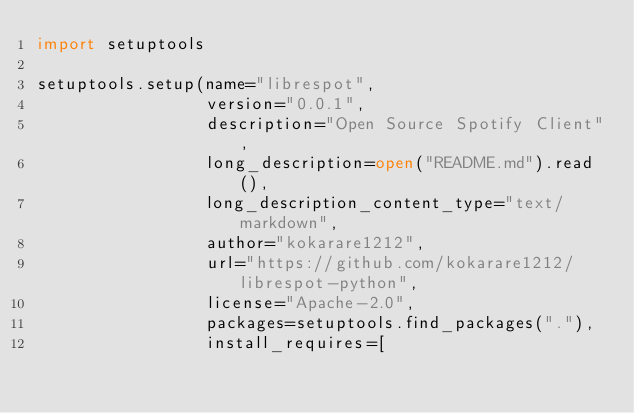<code> <loc_0><loc_0><loc_500><loc_500><_Python_>import setuptools

setuptools.setup(name="librespot",
                 version="0.0.1",
                 description="Open Source Spotify Client",
                 long_description=open("README.md").read(),
                 long_description_content_type="text/markdown",
                 author="kokarare1212",
                 url="https://github.com/kokarare1212/librespot-python",
                 license="Apache-2.0",
                 packages=setuptools.find_packages("."),
                 install_requires=[</code> 